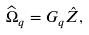Convert formula to latex. <formula><loc_0><loc_0><loc_500><loc_500>\widehat { \Omega } _ { q } = G _ { q } \hat { Z } ,</formula> 